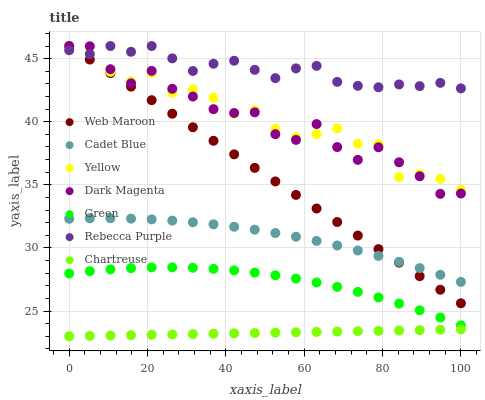Does Chartreuse have the minimum area under the curve?
Answer yes or no. Yes. Does Rebecca Purple have the maximum area under the curve?
Answer yes or no. Yes. Does Dark Magenta have the minimum area under the curve?
Answer yes or no. No. Does Dark Magenta have the maximum area under the curve?
Answer yes or no. No. Is Chartreuse the smoothest?
Answer yes or no. Yes. Is Dark Magenta the roughest?
Answer yes or no. Yes. Is Web Maroon the smoothest?
Answer yes or no. No. Is Web Maroon the roughest?
Answer yes or no. No. Does Chartreuse have the lowest value?
Answer yes or no. Yes. Does Dark Magenta have the lowest value?
Answer yes or no. No. Does Rebecca Purple have the highest value?
Answer yes or no. Yes. Does Chartreuse have the highest value?
Answer yes or no. No. Is Cadet Blue less than Rebecca Purple?
Answer yes or no. Yes. Is Rebecca Purple greater than Chartreuse?
Answer yes or no. Yes. Does Rebecca Purple intersect Web Maroon?
Answer yes or no. Yes. Is Rebecca Purple less than Web Maroon?
Answer yes or no. No. Is Rebecca Purple greater than Web Maroon?
Answer yes or no. No. Does Cadet Blue intersect Rebecca Purple?
Answer yes or no. No. 